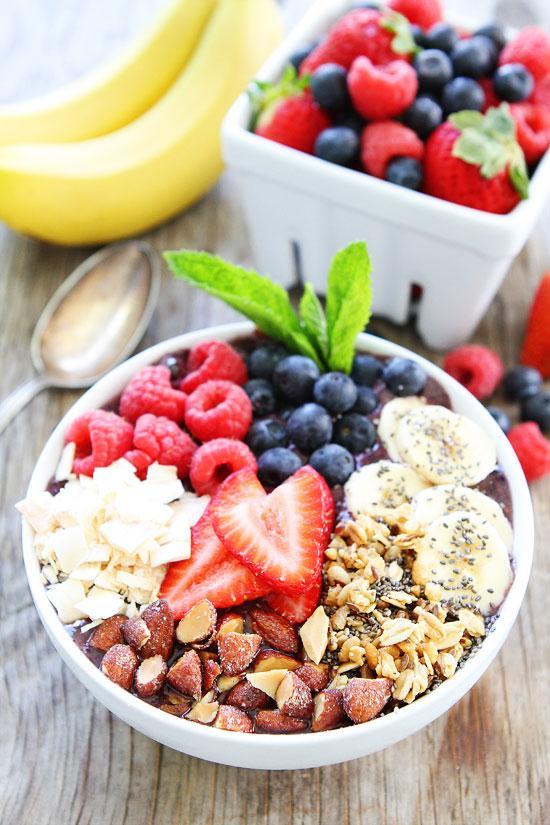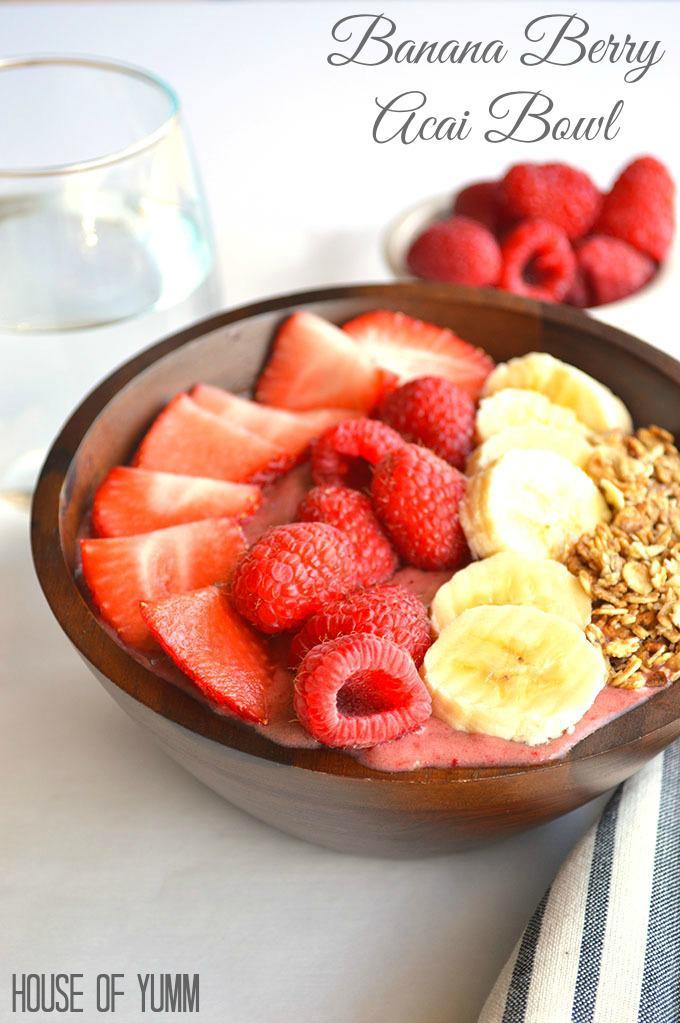The first image is the image on the left, the second image is the image on the right. Examine the images to the left and right. Is the description "The combined images include a white bowl topped with blueberries and other ingredients, a square white container of fruit behind a white bowl, and a blue-striped white cloth next to a bowl." accurate? Answer yes or no. Yes. 